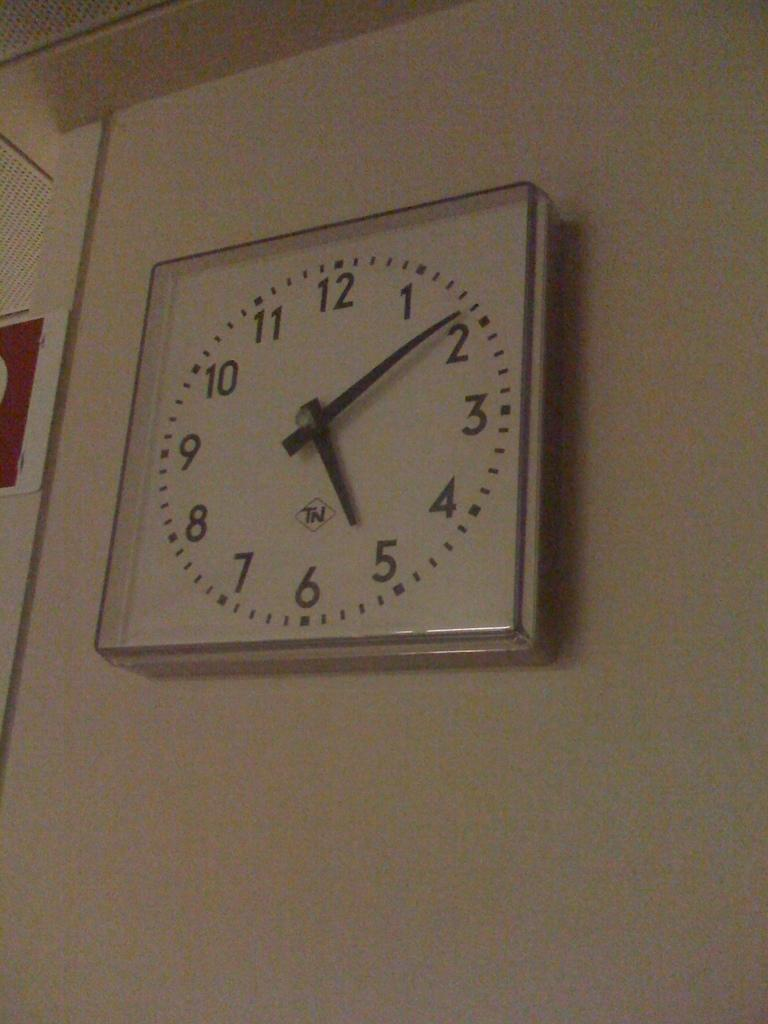<image>
Summarize the visual content of the image. A square clock is on a white wall and it shows the time 5:09. 